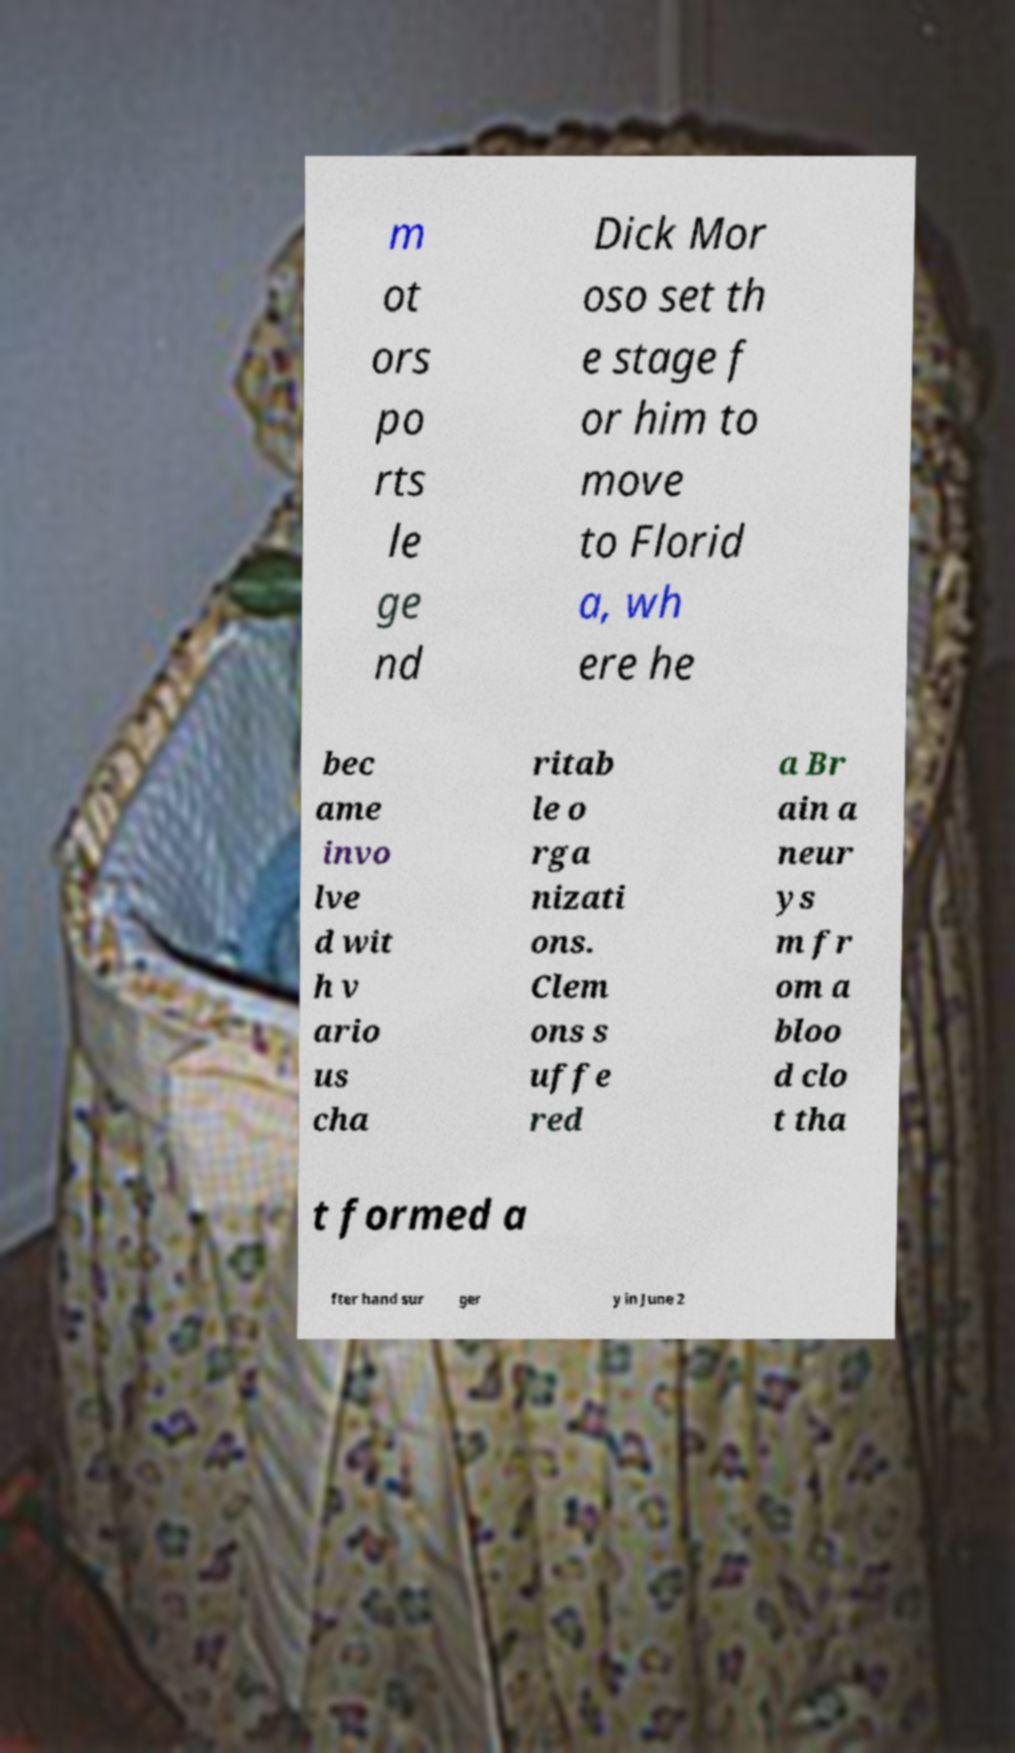There's text embedded in this image that I need extracted. Can you transcribe it verbatim? m ot ors po rts le ge nd Dick Mor oso set th e stage f or him to move to Florid a, wh ere he bec ame invo lve d wit h v ario us cha ritab le o rga nizati ons. Clem ons s uffe red a Br ain a neur ys m fr om a bloo d clo t tha t formed a fter hand sur ger y in June 2 